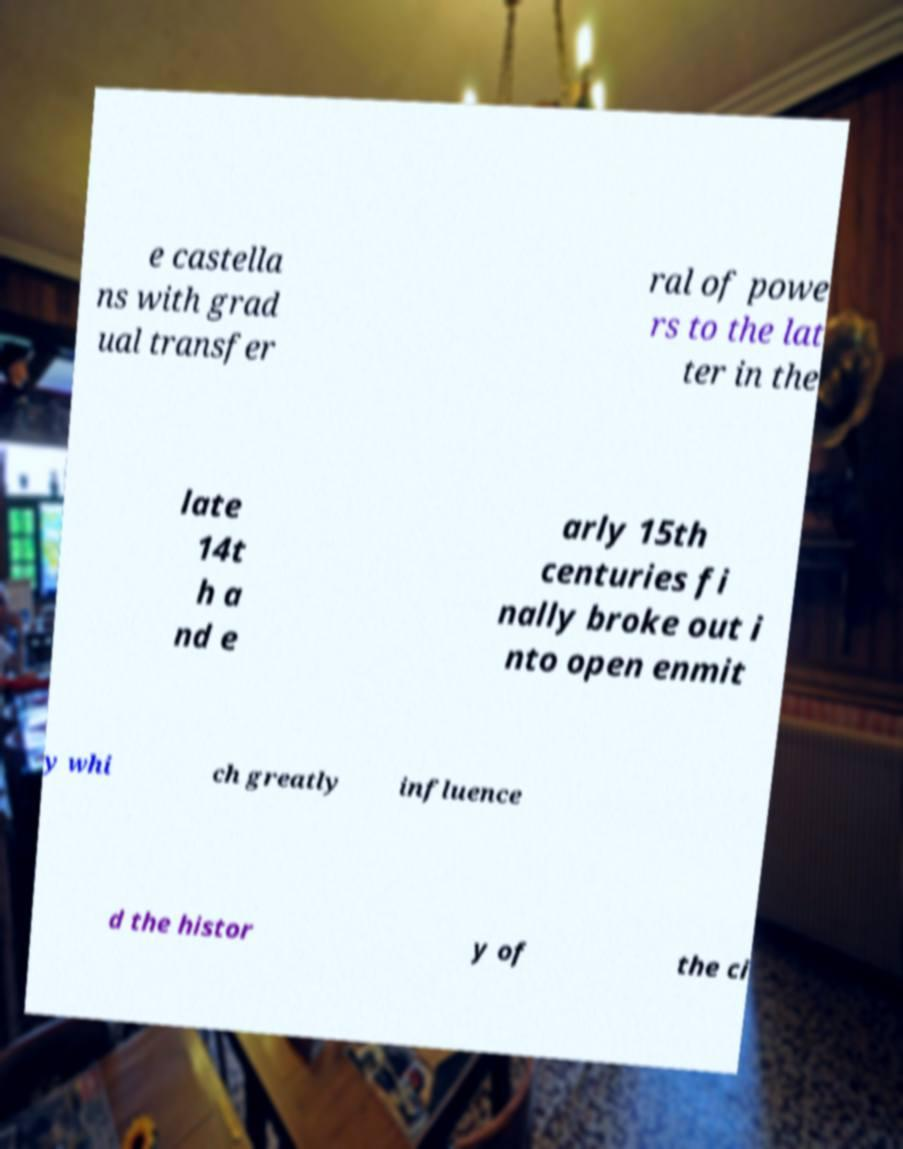Can you accurately transcribe the text from the provided image for me? e castella ns with grad ual transfer ral of powe rs to the lat ter in the late 14t h a nd e arly 15th centuries fi nally broke out i nto open enmit y whi ch greatly influence d the histor y of the ci 